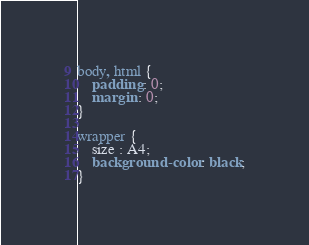<code> <loc_0><loc_0><loc_500><loc_500><_CSS_>body, html {
    padding : 0;
    margin : 0;
}

wrapper {
    size : A4;
    background-color : black;
}</code> 